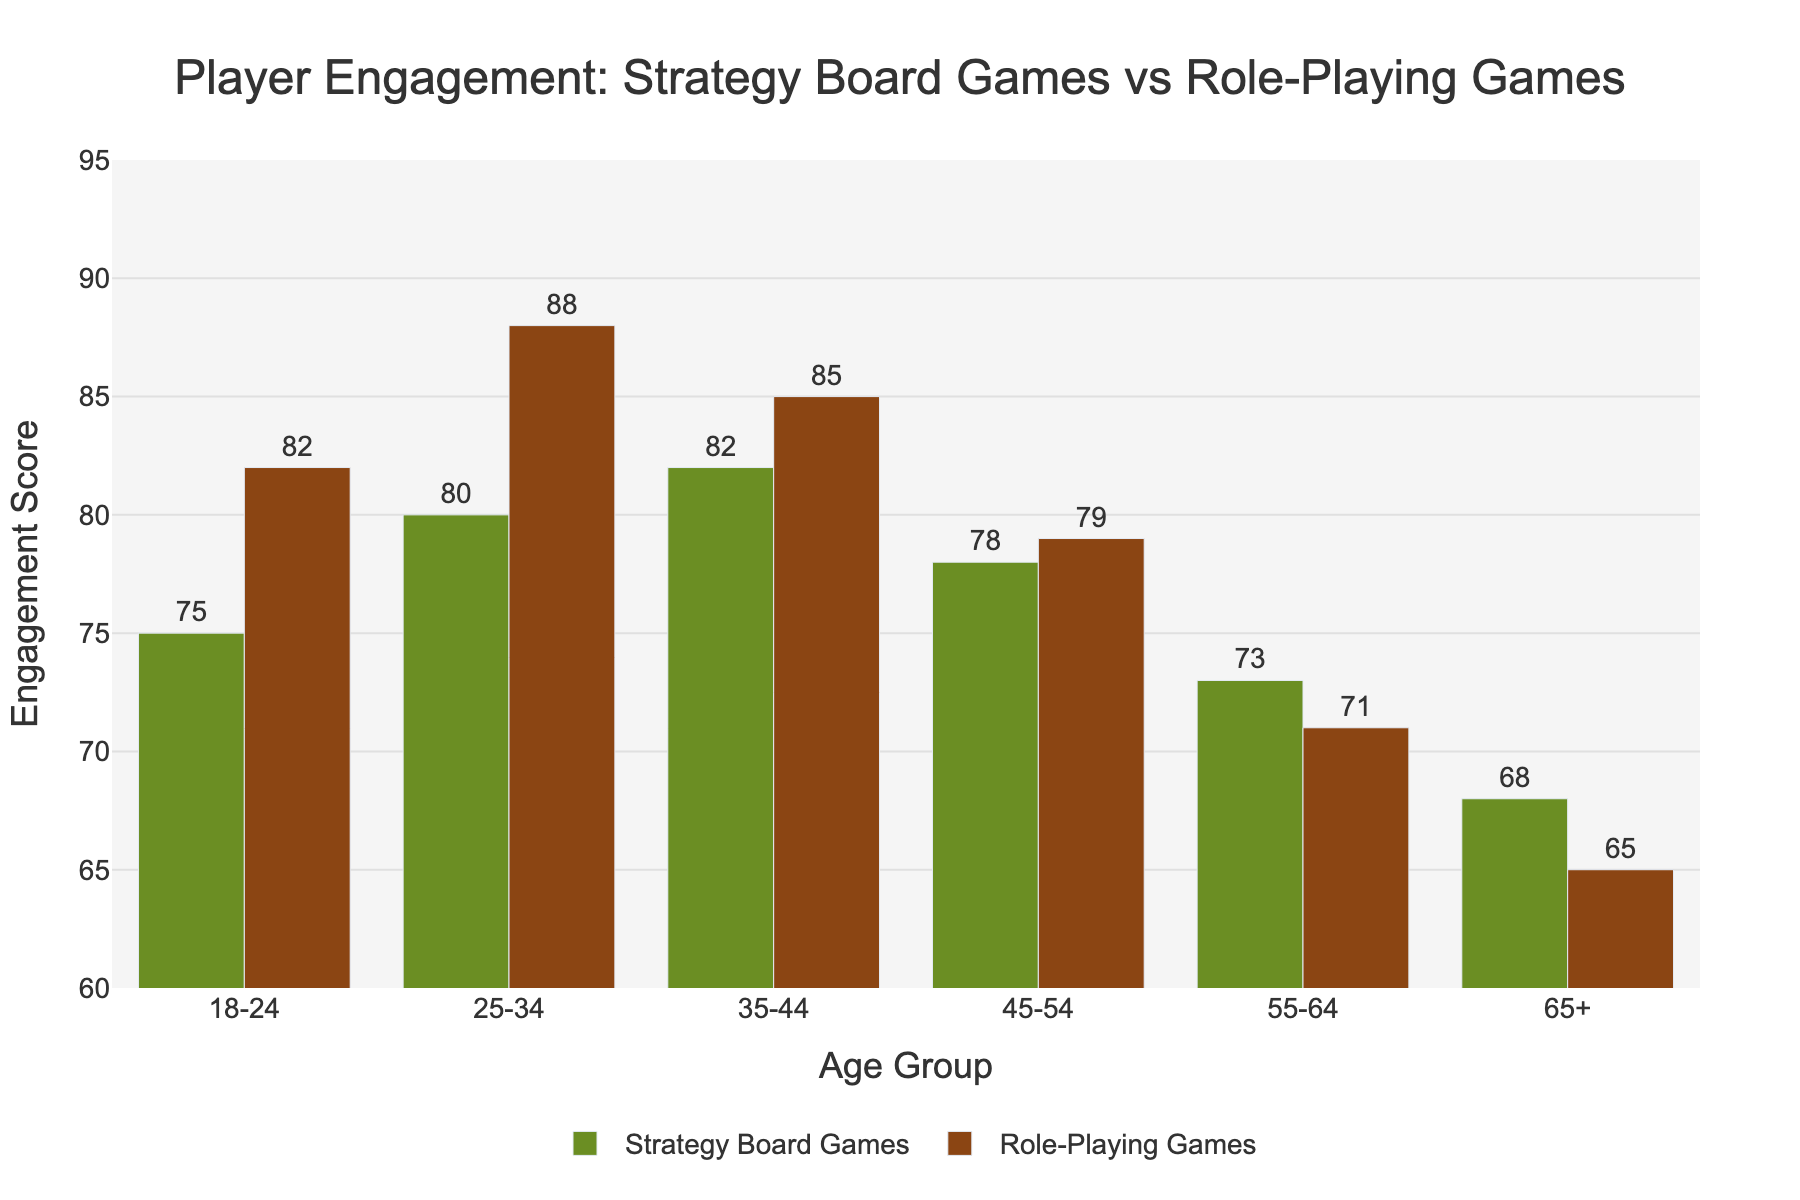What is the highest engagement score for Role-Playing Games? Look at the bar heights in the Role-Playing Games series and identify the highest value. The highest bar is for the 25-34 age group, indicating 88.
Answer: 88 Which age group has the lowest engagement score for Strategy Board Games? Look at the bar heights in the Strategy Board Games series and identify the lowest value. The lowest bar is for the age group 65+ with a value of 68.
Answer: 65+ What is the difference in engagement score between Strategy Board Games and Role-Playing Games for the 18-24 age group? Look at the bars for the 18-24 age group in both series. Subtract the Strategy Board Games score (75) from the Role-Playing Games score (82). The difference is 82 - 75 = 7.
Answer: 7 What is the average engagement score for Role-Playing Games across all age groups? Add all engagement scores for Role-Playing Games and divide by the number of age groups. (82 + 88 + 85 + 79 + 71 + 65) / 6 = 470 / 6 ≈ 78.33.
Answer: ~78.33 Which age group shows a greater engagement in Role-Playing Games compared to Strategy Board Games? Compare the bars for each age group. The 18-24, 25-34, and 45-54 age groups have higher scores in Role-Playing Games compared to Strategy Board Games. Without ambiguity, the concise answer is the 25-34 age group as it has the highest difference (88 vs. 80).
Answer: 25-34 age group Is the engagement score for the age group 35-44 higher in Strategy Board Games or Role-Playing Games? Look at the bars for the 35-44 age group. Strategy Board Games have a score of 82 and Role-Playing Games have a score of 85. Therefore, the score for Role-Playing Games is higher.
Answer: Role-Playing Games How many age groups have a higher engagement in Strategy Board Games compared to Role-Playing Games? Compare the engagement scores for each age group. The age groups 35-44, 55-64, and 65+ have higher scores in Strategy Board Games. So, there are 3 age groups in total.
Answer: 3 What is the cumulative engagement score for Role-Playing Games for age groups from 45-54 to 65+? Sum the engagement scores for the 45-54, 55-64, and 65+ age groups in Role-Playing Games. 79 + 71 + 65 = 215.
Answer: 215 Which age group's engagement score for Strategy Board Games is closest to 80? Compare each age group's score with 80. The closest score is for the 25-34 age group with a value of 80.
Answer: 25-34 How much higher is the engagement score of Role-Playing Games for the 25-34 age group compared to the 65+ age group? Subtract the 65+ age group's score (65) from the 25-34 age group's score (88) for Role-Playing Games. The difference is 88 - 65 = 23.
Answer: 23 